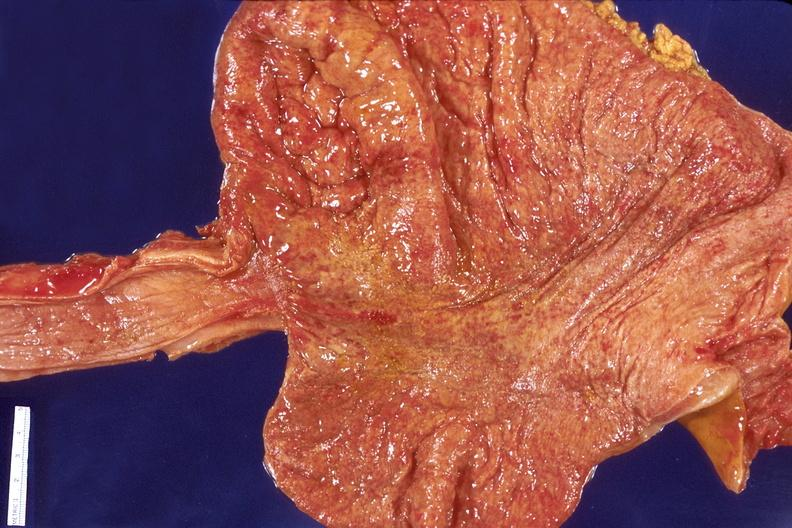what does this image show?
Answer the question using a single word or phrase. Stomach 